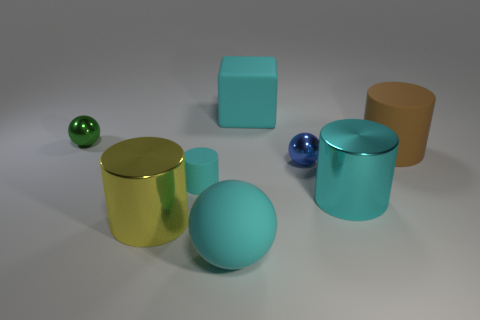There is a shiny cylinder that is right of the cyan cylinder to the left of the large cyan rubber object that is behind the cyan rubber cylinder; what is its size?
Give a very brief answer. Large. The small sphere that is behind the small shiny sphere on the right side of the small thing that is behind the tiny blue ball is what color?
Make the answer very short. Green. What shape is the yellow shiny object that is the same size as the cyan ball?
Offer a very short reply. Cylinder. Is there anything else that has the same size as the blue thing?
Provide a succinct answer. Yes. There is a green sphere that is on the left side of the large brown object; does it have the same size as the rubber thing behind the large matte cylinder?
Offer a terse response. No. There is a green object that is behind the blue ball; how big is it?
Offer a very short reply. Small. There is a cube that is the same color as the small cylinder; what is its material?
Your response must be concise. Rubber. What is the color of the block that is the same size as the brown rubber thing?
Your answer should be very brief. Cyan. Does the yellow cylinder have the same size as the green thing?
Your response must be concise. No. There is a sphere that is both to the right of the green metallic thing and behind the yellow cylinder; how big is it?
Offer a very short reply. Small. 